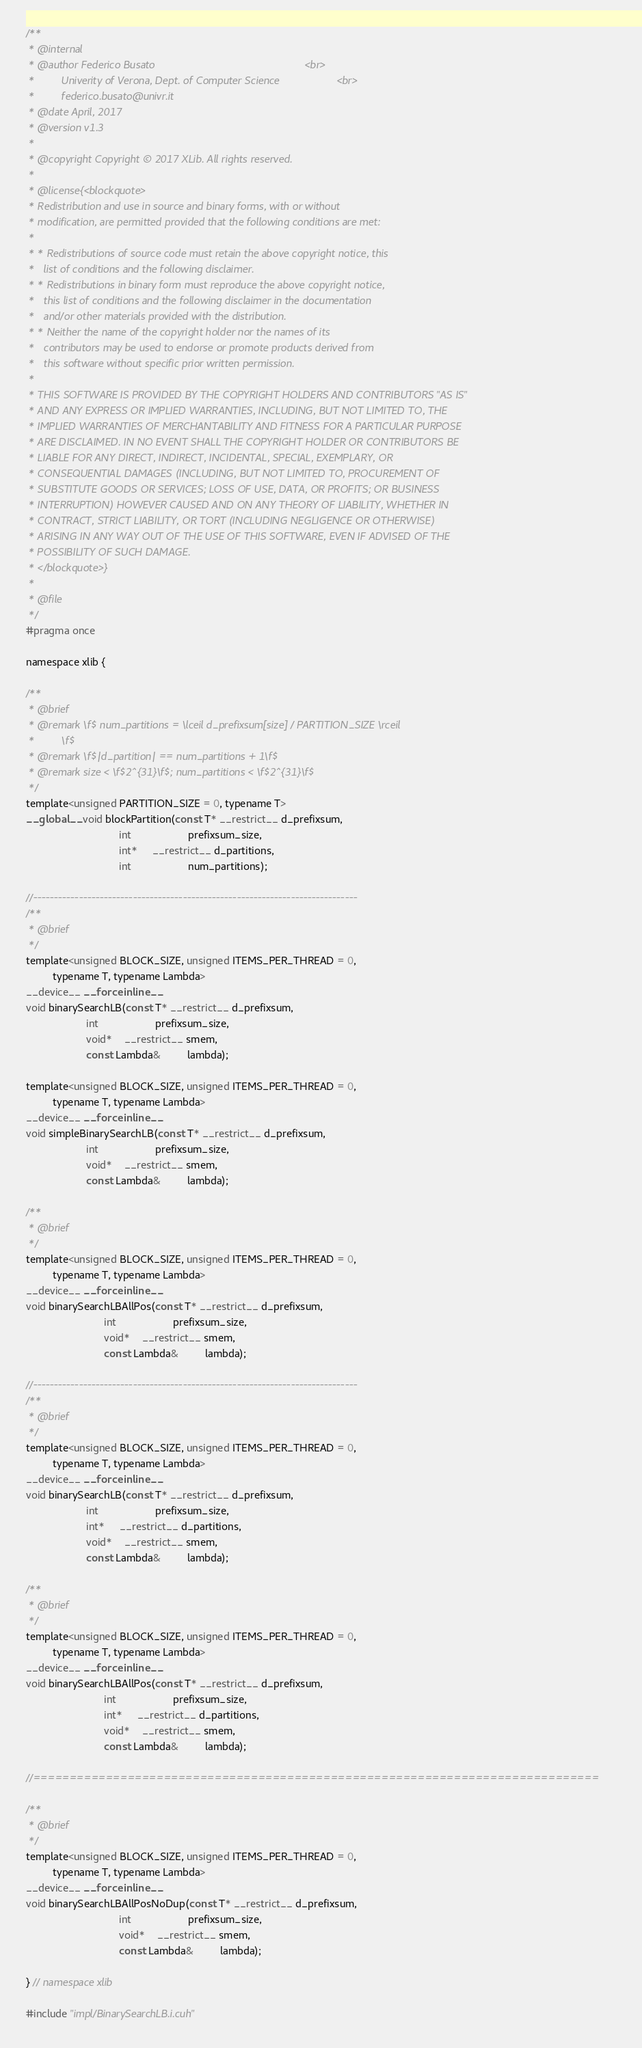<code> <loc_0><loc_0><loc_500><loc_500><_Cuda_>/**
 * @internal
 * @author Federico Busato                                                  <br>
 *         Univerity of Verona, Dept. of Computer Science                   <br>
 *         federico.busato@univr.it
 * @date April, 2017
 * @version v1.3
 *
 * @copyright Copyright © 2017 XLib. All rights reserved.
 *
 * @license{<blockquote>
 * Redistribution and use in source and binary forms, with or without
 * modification, are permitted provided that the following conditions are met:
 *
 * * Redistributions of source code must retain the above copyright notice, this
 *   list of conditions and the following disclaimer.
 * * Redistributions in binary form must reproduce the above copyright notice,
 *   this list of conditions and the following disclaimer in the documentation
 *   and/or other materials provided with the distribution.
 * * Neither the name of the copyright holder nor the names of its
 *   contributors may be used to endorse or promote products derived from
 *   this software without specific prior written permission.
 *
 * THIS SOFTWARE IS PROVIDED BY THE COPYRIGHT HOLDERS AND CONTRIBUTORS "AS IS"
 * AND ANY EXPRESS OR IMPLIED WARRANTIES, INCLUDING, BUT NOT LIMITED TO, THE
 * IMPLIED WARRANTIES OF MERCHANTABILITY AND FITNESS FOR A PARTICULAR PURPOSE
 * ARE DISCLAIMED. IN NO EVENT SHALL THE COPYRIGHT HOLDER OR CONTRIBUTORS BE
 * LIABLE FOR ANY DIRECT, INDIRECT, INCIDENTAL, SPECIAL, EXEMPLARY, OR
 * CONSEQUENTIAL DAMAGES (INCLUDING, BUT NOT LIMITED TO, PROCUREMENT OF
 * SUBSTITUTE GOODS OR SERVICES; LOSS OF USE, DATA, OR PROFITS; OR BUSINESS
 * INTERRUPTION) HOWEVER CAUSED AND ON ANY THEORY OF LIABILITY, WHETHER IN
 * CONTRACT, STRICT LIABILITY, OR TORT (INCLUDING NEGLIGENCE OR OTHERWISE)
 * ARISING IN ANY WAY OUT OF THE USE OF THIS SOFTWARE, EVEN IF ADVISED OF THE
 * POSSIBILITY OF SUCH DAMAGE.
 * </blockquote>}
 *
 * @file
 */
#pragma once

namespace xlib {

/**
 * @brief
 * @remark \f$ num_partitions = \lceil d_prefixsum[size] / PARTITION_SIZE \rceil
 *         \f$
 * @remark \f$|d_partition| == num_partitions + 1\f$
 * @remark size < \f$2^{31}\f$; num_partitions < \f$2^{31}\f$
 */
template<unsigned PARTITION_SIZE = 0, typename T>
__global__ void blockPartition(const T* __restrict__ d_prefixsum,
                               int                   prefixsum_size,
                               int*     __restrict__ d_partitions,
                               int                   num_partitions);

//------------------------------------------------------------------------------
/**
 * @brief
 */
template<unsigned BLOCK_SIZE, unsigned ITEMS_PER_THREAD = 0,
         typename T, typename Lambda>
__device__ __forceinline__
void binarySearchLB(const T* __restrict__ d_prefixsum,
                    int                   prefixsum_size,
                    void*    __restrict__ smem,
                    const Lambda&         lambda);

template<unsigned BLOCK_SIZE, unsigned ITEMS_PER_THREAD = 0,
         typename T, typename Lambda>
__device__ __forceinline__
void simpleBinarySearchLB(const T* __restrict__ d_prefixsum,
                    int                   prefixsum_size,
                    void*    __restrict__ smem,
                    const Lambda&         lambda);

/**
 * @brief
 */
template<unsigned BLOCK_SIZE, unsigned ITEMS_PER_THREAD = 0,
         typename T, typename Lambda>
__device__ __forceinline__
void binarySearchLBAllPos(const T* __restrict__ d_prefixsum,
                          int                   prefixsum_size,
                          void*    __restrict__ smem,
                          const Lambda&         lambda);

//------------------------------------------------------------------------------
/**
 * @brief
 */
template<unsigned BLOCK_SIZE, unsigned ITEMS_PER_THREAD = 0,
         typename T, typename Lambda>
__device__ __forceinline__
void binarySearchLB(const T* __restrict__ d_prefixsum,
                    int                   prefixsum_size,
                    int*     __restrict__ d_partitions,
                    void*    __restrict__ smem,
                    const Lambda&         lambda);

/**
 * @brief
 */
template<unsigned BLOCK_SIZE, unsigned ITEMS_PER_THREAD = 0,
         typename T, typename Lambda>
__device__ __forceinline__
void binarySearchLBAllPos(const T* __restrict__ d_prefixsum,
                          int                   prefixsum_size,
                          int*     __restrict__ d_partitions,
                          void*    __restrict__ smem,
                          const Lambda&         lambda);

//==============================================================================

/**
 * @brief
 */
template<unsigned BLOCK_SIZE, unsigned ITEMS_PER_THREAD = 0,
         typename T, typename Lambda>
__device__ __forceinline__
void binarySearchLBAllPosNoDup(const T* __restrict__ d_prefixsum,
                               int                   prefixsum_size,
                               void*    __restrict__ smem,
                               const Lambda&         lambda);

} // namespace xlib

#include "impl/BinarySearchLB.i.cuh"
</code> 